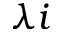Convert formula to latex. <formula><loc_0><loc_0><loc_500><loc_500>\lambda i</formula> 